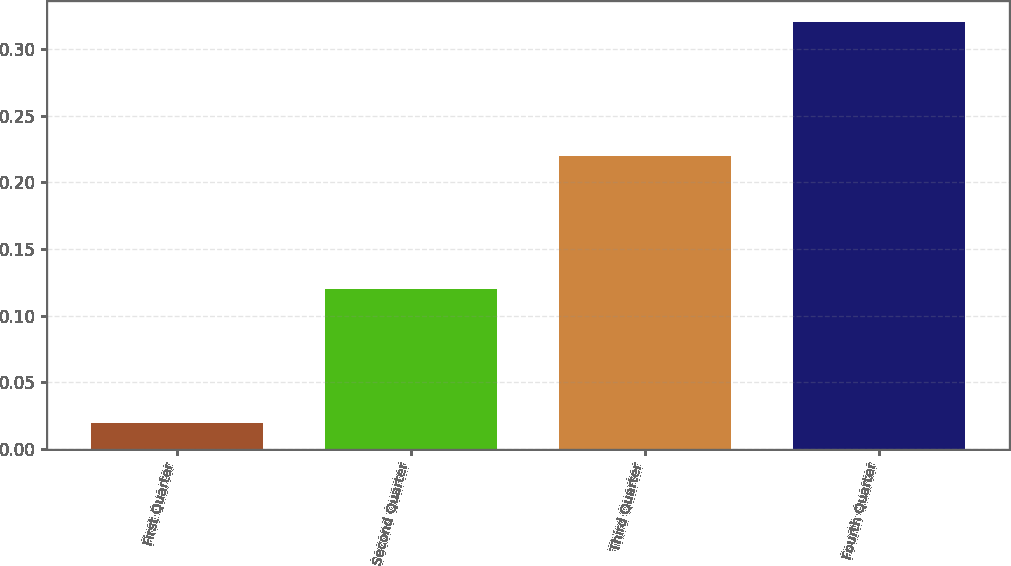<chart> <loc_0><loc_0><loc_500><loc_500><bar_chart><fcel>First Quarter<fcel>Second Quarter<fcel>Third Quarter<fcel>Fourth Quarter<nl><fcel>0.02<fcel>0.12<fcel>0.22<fcel>0.32<nl></chart> 